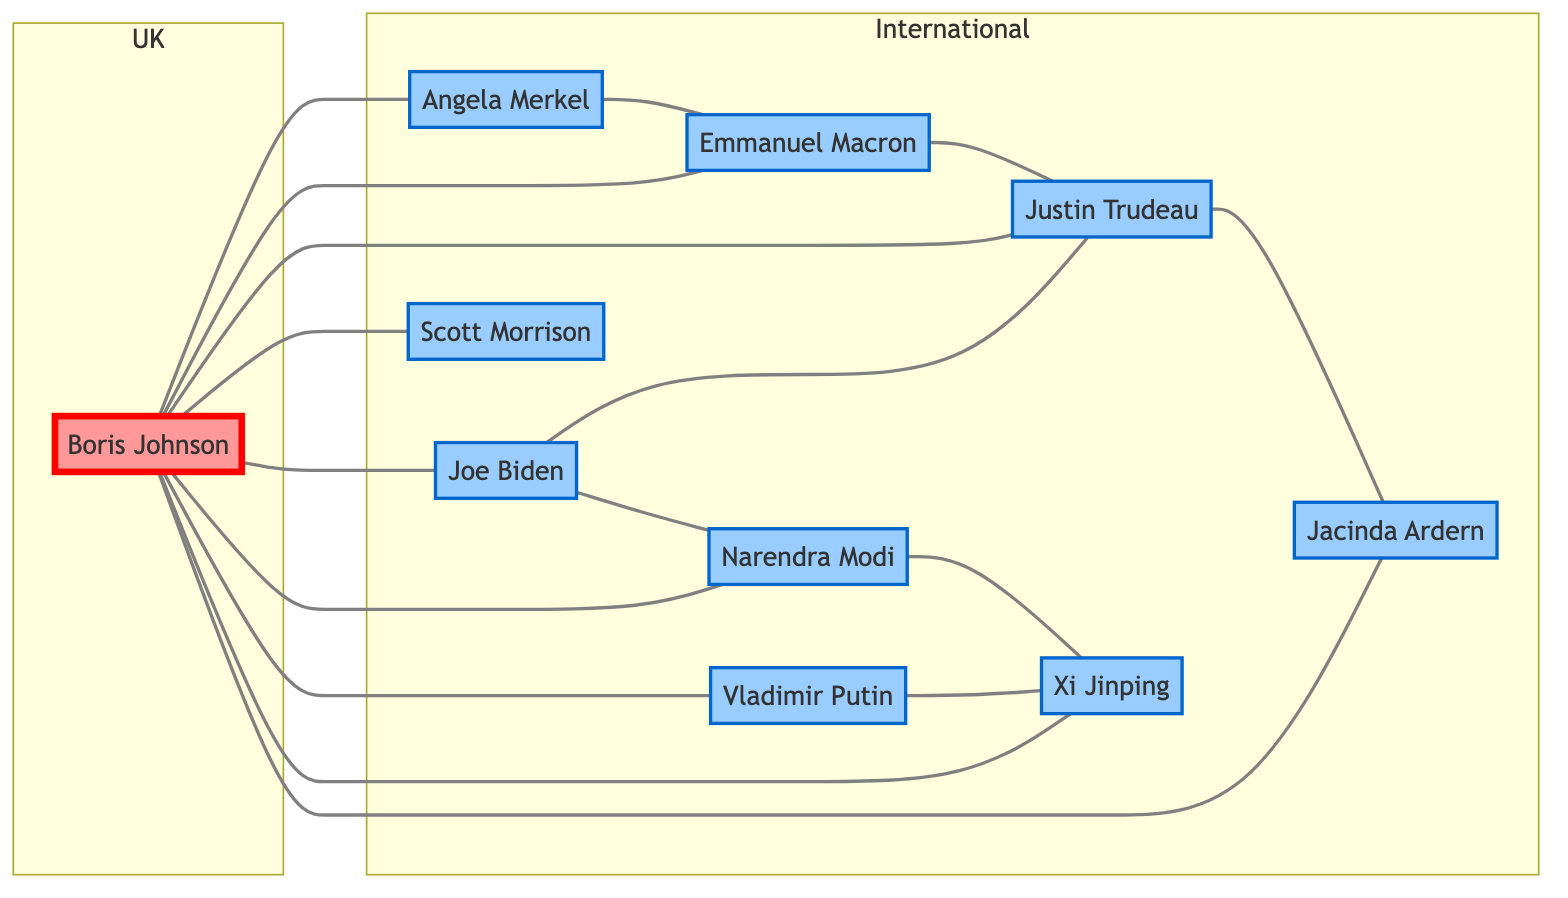What is the total number of nodes in the graph? The graph contains nodes representing political figures. By counting all unique entries in the "nodes" section of the data provided, we find there are 10 nodes.
Answer: 10 How many edges connect Boris Johnson to international leaders? Boris Johnson has edges connecting him to multiple international leaders. By examining the edges originating from Boris Johnson, we find he is connected to 8 different international figures.
Answer: 8 Who is directly connected to Angela Merkel? Angela Merkel is connected to Emmanuel Macron and Boris Johnson as shown in the edges. Therefore, there are two direct connections.
Answer: Boris Johnson, Emmanuel Macron Which international leader has the most connections? By reviewing the edges to and from each international leader, it is evident that Justin Trudeau is directly connected to four leaders (Boris Johnson, Emmanuel Macron, Jacinda Ardern, and Joe Biden).
Answer: Justin Trudeau What is the relationship between Narendra Modi and Xi Jinping? Narendra Modi and Xi Jinping are connected by a direct edge in the graph, indicating they have a collaborative link.
Answer: Connected How many total connections exist in the graph? The total number of connections, or edges, represent the number of unique collaborations between the figures. By counting all listed edges, we find there are 15 collaborations.
Answer: 15 Which leader is only connected to Boris Johnson? By evaluating the edges of each leader, Scott Morrison is unique in being directly connected only to Boris Johnson.
Answer: Scott Morrison Which two leaders share the most connections? By analyzing the connections, we see that both Boris Johnson and Justin Trudeau connect to various leaders, but Boris Johnson ties with the most (8 connections) while Justin Trudeau is second with 4. Therefore, the answer is Boris Johnson.
Answer: Boris Johnson How many distinct nodes belong to the 'UK' subgraph? The 'UK' subgraph contains only Boris Johnson as its representative node, making it distinct and singular in representation for the United Kingdom.
Answer: 1 